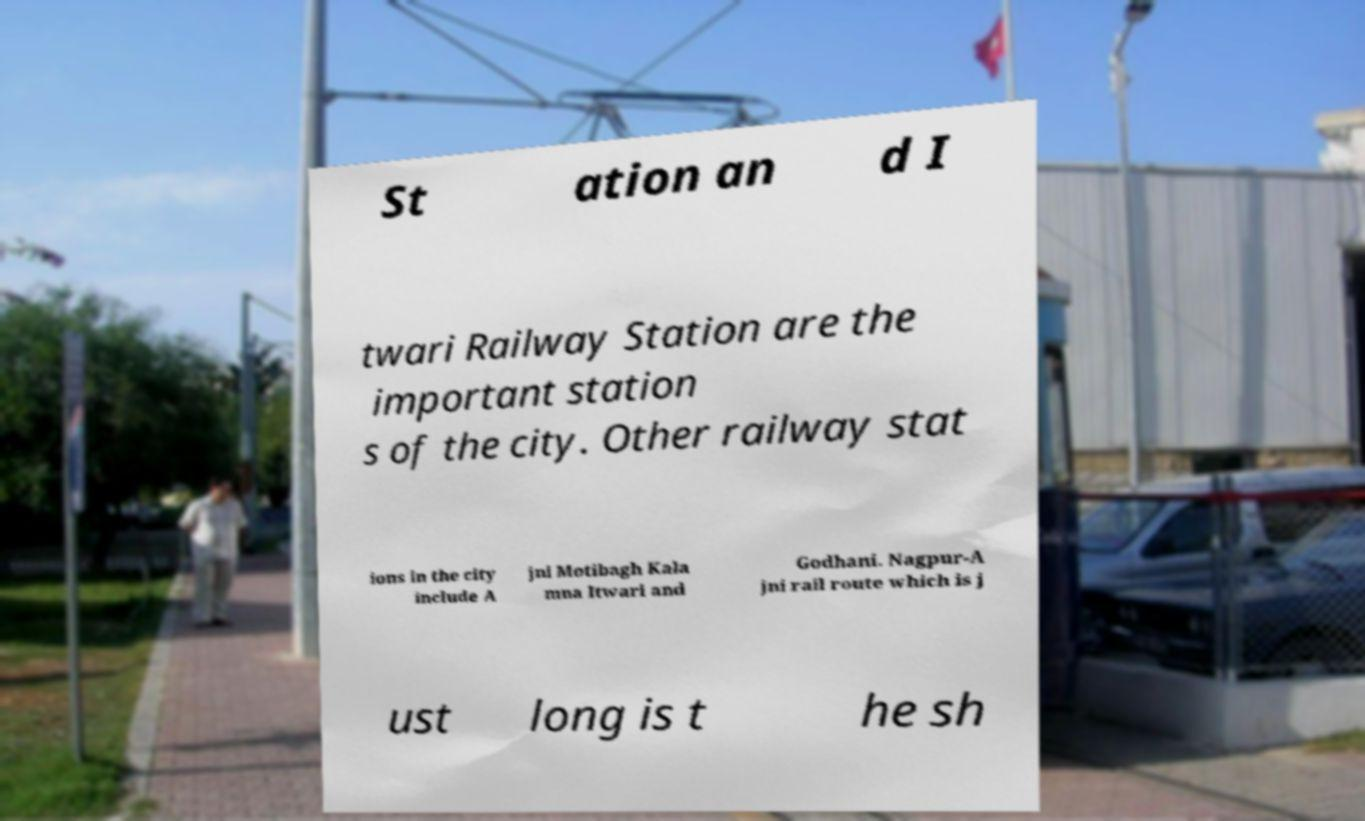Could you assist in decoding the text presented in this image and type it out clearly? St ation an d I twari Railway Station are the important station s of the city. Other railway stat ions in the city include A jni Motibagh Kala mna Itwari and Godhani. Nagpur-A jni rail route which is j ust long is t he sh 